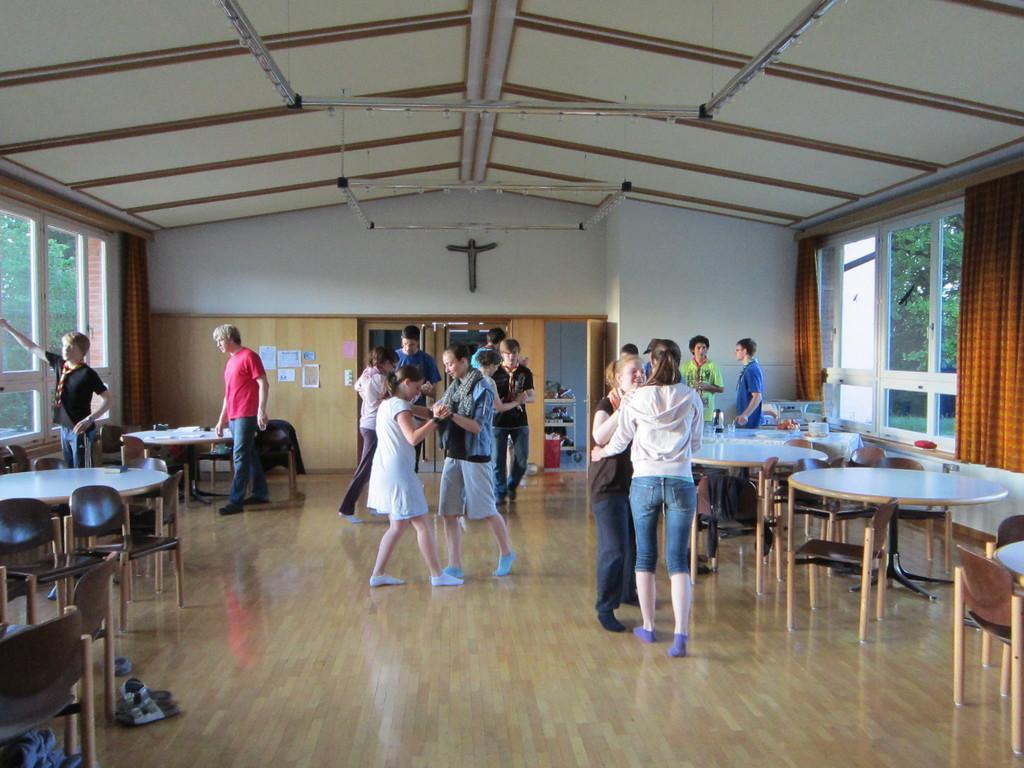Can you describe this image briefly? This is the picture of a place where we have some chairs and tables around the room and some people dancing holding each other there are orange color curtains to the windows and some lights to the roof. 